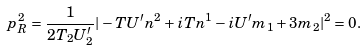Convert formula to latex. <formula><loc_0><loc_0><loc_500><loc_500>p _ { R } ^ { 2 } = \frac { 1 } { 2 T _ { 2 } U _ { 2 } ^ { \prime } } | - { T } U ^ { \prime } n ^ { 2 } + i { T } n ^ { 1 } - i U ^ { \prime } m _ { 1 } + 3 m _ { 2 } | ^ { 2 } = 0 .</formula> 